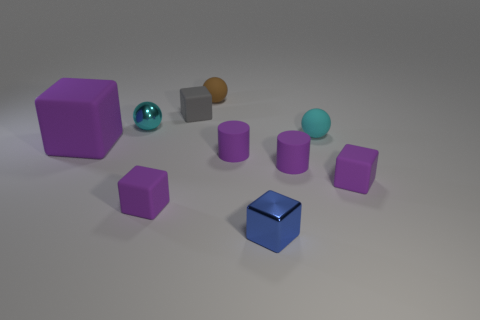Is there a brown rubber thing that has the same shape as the tiny gray object?
Offer a terse response. No. There is a metal thing to the right of the tiny matte block behind the cyan shiny object; what shape is it?
Keep it short and to the point. Cube. What is the color of the cube that is right of the blue object?
Make the answer very short. Purple. The cyan sphere that is the same material as the blue block is what size?
Give a very brief answer. Small. There is a gray object that is the same shape as the tiny blue thing; what is its size?
Offer a very short reply. Small. Are there any brown matte balls?
Ensure brevity in your answer.  Yes. What number of objects are either purple cylinders that are to the right of the blue block or tiny brown matte spheres?
Make the answer very short. 2. There is a blue thing that is the same size as the gray object; what material is it?
Your answer should be compact. Metal. What color is the small rubber cube to the right of the rubber ball to the right of the brown rubber ball?
Your response must be concise. Purple. What number of brown rubber spheres are left of the small gray block?
Provide a succinct answer. 0. 